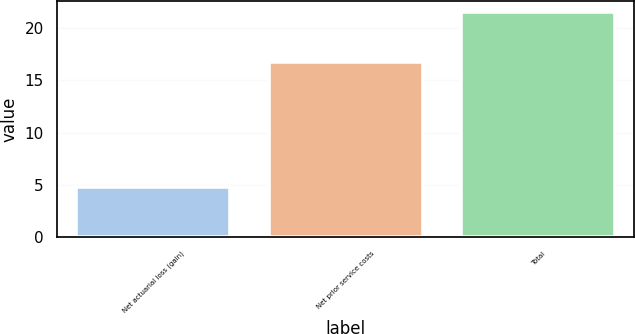Convert chart. <chart><loc_0><loc_0><loc_500><loc_500><bar_chart><fcel>Net actuarial loss (gain)<fcel>Net prior service costs<fcel>Total<nl><fcel>4.8<fcel>16.7<fcel>21.5<nl></chart> 